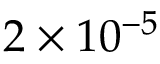Convert formula to latex. <formula><loc_0><loc_0><loc_500><loc_500>2 \times 1 0 ^ { - 5 }</formula> 